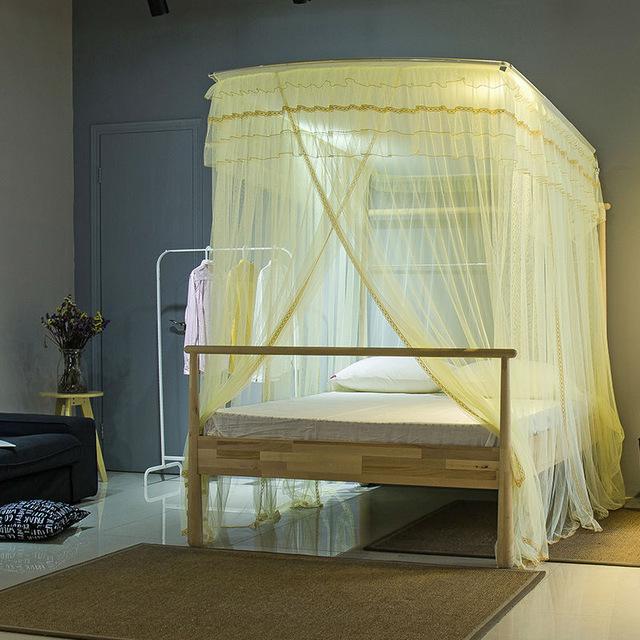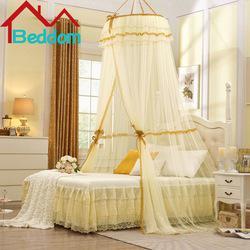The first image is the image on the left, the second image is the image on the right. For the images displayed, is the sentence "Both images show four-posted beds with curtain type canopies." factually correct? Answer yes or no. No. The first image is the image on the left, the second image is the image on the right. Examine the images to the left and right. Is the description "The canopy bed on the right has a two-drawer chest next to it." accurate? Answer yes or no. Yes. 